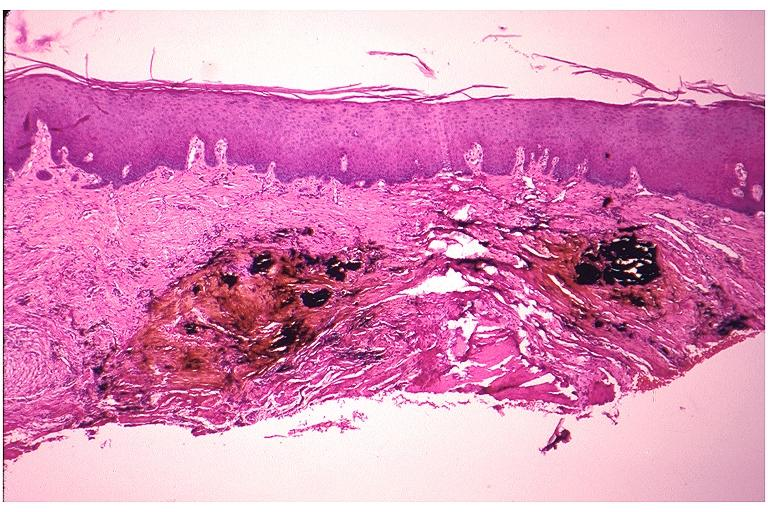what does this image show?
Answer the question using a single word or phrase. Amalgam tattoo 